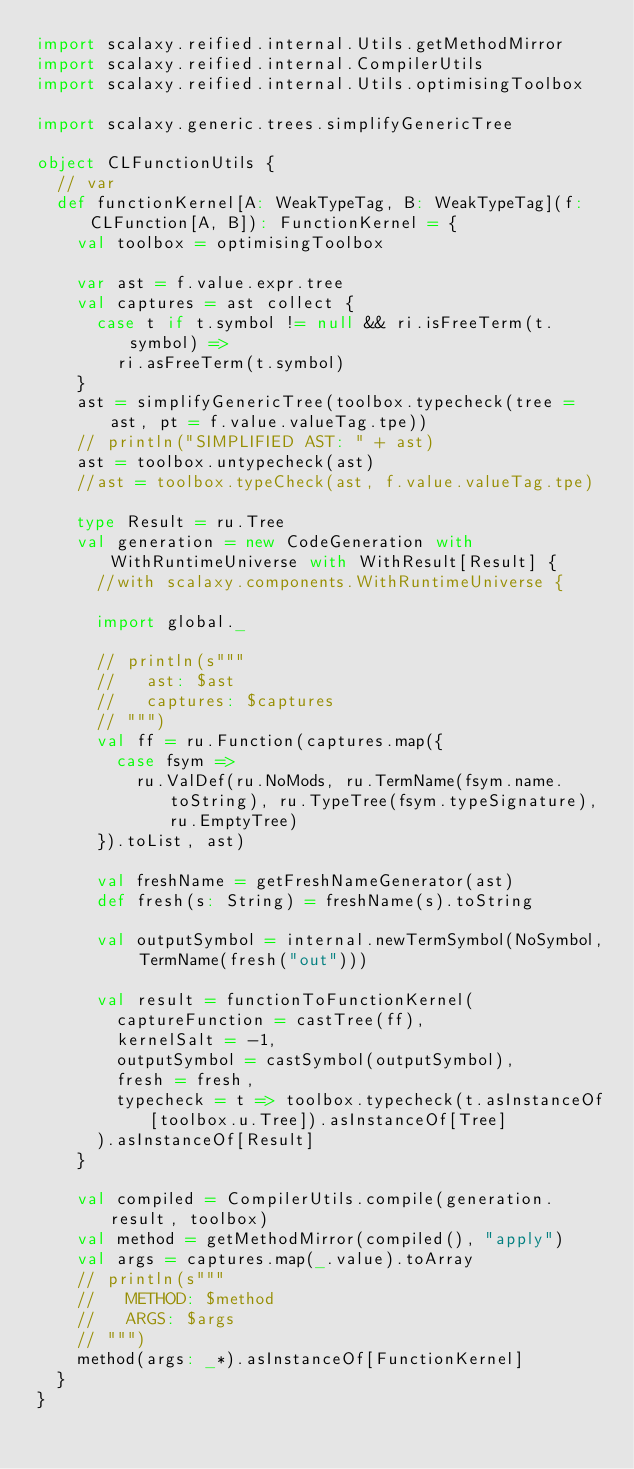<code> <loc_0><loc_0><loc_500><loc_500><_Scala_>import scalaxy.reified.internal.Utils.getMethodMirror
import scalaxy.reified.internal.CompilerUtils
import scalaxy.reified.internal.Utils.optimisingToolbox

import scalaxy.generic.trees.simplifyGenericTree

object CLFunctionUtils {
  // var 
  def functionKernel[A: WeakTypeTag, B: WeakTypeTag](f: CLFunction[A, B]): FunctionKernel = {
    val toolbox = optimisingToolbox

    var ast = f.value.expr.tree
    val captures = ast collect {
      case t if t.symbol != null && ri.isFreeTerm(t.symbol) =>
        ri.asFreeTerm(t.symbol)
    }
    ast = simplifyGenericTree(toolbox.typecheck(tree = ast, pt = f.value.valueTag.tpe))
    // println("SIMPLIFIED AST: " + ast)
    ast = toolbox.untypecheck(ast)
    //ast = toolbox.typeCheck(ast, f.value.valueTag.tpe)

    type Result = ru.Tree
    val generation = new CodeGeneration with WithRuntimeUniverse with WithResult[Result] {
      //with scalaxy.components.WithRuntimeUniverse {

      import global._

      // println(s"""
      //   ast: $ast
      //   captures: $captures
      // """)
      val ff = ru.Function(captures.map({
        case fsym =>
          ru.ValDef(ru.NoMods, ru.TermName(fsym.name.toString), ru.TypeTree(fsym.typeSignature), ru.EmptyTree)
      }).toList, ast)

      val freshName = getFreshNameGenerator(ast)
      def fresh(s: String) = freshName(s).toString

      val outputSymbol = internal.newTermSymbol(NoSymbol, TermName(fresh("out")))

      val result = functionToFunctionKernel(
        captureFunction = castTree(ff),
        kernelSalt = -1,
        outputSymbol = castSymbol(outputSymbol),
        fresh = fresh,
        typecheck = t => toolbox.typecheck(t.asInstanceOf[toolbox.u.Tree]).asInstanceOf[Tree]
      ).asInstanceOf[Result]
    }

    val compiled = CompilerUtils.compile(generation.result, toolbox)
    val method = getMethodMirror(compiled(), "apply")
    val args = captures.map(_.value).toArray
    // println(s"""
    //   METHOD: $method
    //   ARGS: $args
    // """)
    method(args: _*).asInstanceOf[FunctionKernel]
  }
}
</code> 